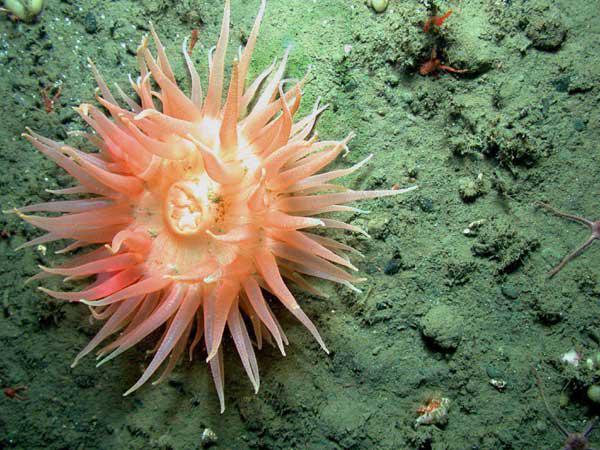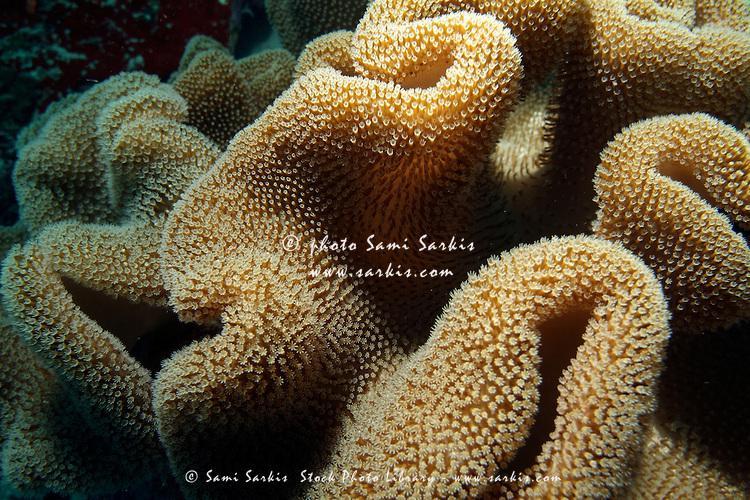The first image is the image on the left, the second image is the image on the right. Given the left and right images, does the statement "One image shows a flower-look anemone with tapering tendrils around a flat center, and the other shows one large anemone with densely-packed neutral-colored tendrils." hold true? Answer yes or no. Yes. 